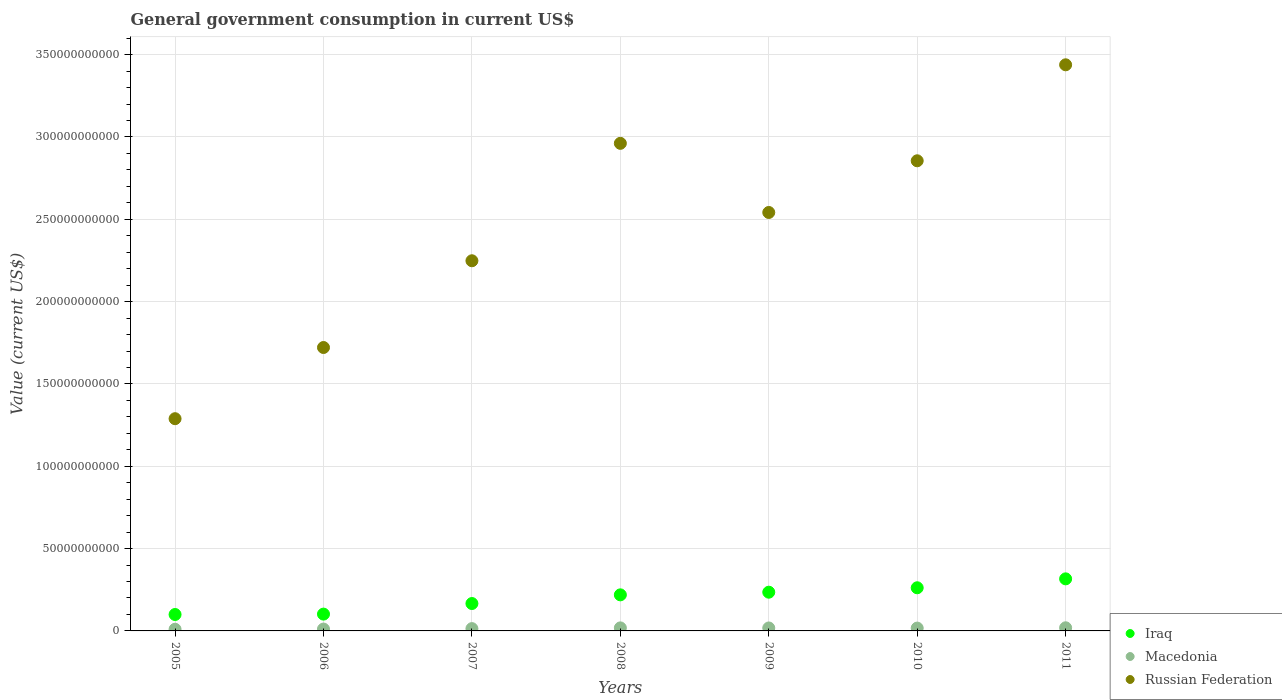How many different coloured dotlines are there?
Keep it short and to the point. 3. What is the government conusmption in Iraq in 2007?
Provide a succinct answer. 1.66e+1. Across all years, what is the maximum government conusmption in Russian Federation?
Your answer should be very brief. 3.44e+11. Across all years, what is the minimum government conusmption in Russian Federation?
Your answer should be very brief. 1.29e+11. In which year was the government conusmption in Russian Federation minimum?
Offer a very short reply. 2005. What is the total government conusmption in Iraq in the graph?
Provide a short and direct response. 1.40e+11. What is the difference between the government conusmption in Macedonia in 2006 and that in 2010?
Your answer should be very brief. -5.88e+08. What is the difference between the government conusmption in Macedonia in 2005 and the government conusmption in Iraq in 2009?
Ensure brevity in your answer.  -2.25e+1. What is the average government conusmption in Macedonia per year?
Offer a very short reply. 1.54e+09. In the year 2011, what is the difference between the government conusmption in Macedonia and government conusmption in Iraq?
Your answer should be compact. -2.97e+1. What is the ratio of the government conusmption in Macedonia in 2007 to that in 2009?
Keep it short and to the point. 0.78. Is the government conusmption in Russian Federation in 2005 less than that in 2007?
Provide a short and direct response. Yes. What is the difference between the highest and the second highest government conusmption in Macedonia?
Give a very brief answer. 6.01e+07. What is the difference between the highest and the lowest government conusmption in Russian Federation?
Keep it short and to the point. 2.15e+11. Is it the case that in every year, the sum of the government conusmption in Russian Federation and government conusmption in Iraq  is greater than the government conusmption in Macedonia?
Your answer should be compact. Yes. Is the government conusmption in Iraq strictly greater than the government conusmption in Macedonia over the years?
Offer a terse response. Yes. Is the government conusmption in Russian Federation strictly less than the government conusmption in Macedonia over the years?
Provide a short and direct response. No. How many dotlines are there?
Provide a short and direct response. 3. How many years are there in the graph?
Your response must be concise. 7. What is the difference between two consecutive major ticks on the Y-axis?
Ensure brevity in your answer.  5.00e+1. Are the values on the major ticks of Y-axis written in scientific E-notation?
Your answer should be compact. No. How are the legend labels stacked?
Give a very brief answer. Vertical. What is the title of the graph?
Make the answer very short. General government consumption in current US$. Does "North America" appear as one of the legend labels in the graph?
Offer a terse response. No. What is the label or title of the Y-axis?
Your answer should be compact. Value (current US$). What is the Value (current US$) in Iraq in 2005?
Your answer should be compact. 9.98e+09. What is the Value (current US$) of Macedonia in 2005?
Your answer should be very brief. 1.01e+09. What is the Value (current US$) in Russian Federation in 2005?
Provide a succinct answer. 1.29e+11. What is the Value (current US$) of Iraq in 2006?
Offer a terse response. 1.02e+1. What is the Value (current US$) of Macedonia in 2006?
Your answer should be very brief. 1.13e+09. What is the Value (current US$) in Russian Federation in 2006?
Offer a terse response. 1.72e+11. What is the Value (current US$) in Iraq in 2007?
Provide a short and direct response. 1.66e+1. What is the Value (current US$) in Macedonia in 2007?
Ensure brevity in your answer.  1.40e+09. What is the Value (current US$) in Russian Federation in 2007?
Provide a succinct answer. 2.25e+11. What is the Value (current US$) in Iraq in 2008?
Your answer should be compact. 2.19e+1. What is the Value (current US$) of Macedonia in 2008?
Offer a terse response. 1.84e+09. What is the Value (current US$) of Russian Federation in 2008?
Provide a succinct answer. 2.96e+11. What is the Value (current US$) in Iraq in 2009?
Offer a very short reply. 2.35e+1. What is the Value (current US$) in Macedonia in 2009?
Provide a short and direct response. 1.79e+09. What is the Value (current US$) in Russian Federation in 2009?
Ensure brevity in your answer.  2.54e+11. What is the Value (current US$) of Iraq in 2010?
Offer a terse response. 2.62e+1. What is the Value (current US$) of Macedonia in 2010?
Your answer should be very brief. 1.72e+09. What is the Value (current US$) in Russian Federation in 2010?
Your answer should be very brief. 2.86e+11. What is the Value (current US$) of Iraq in 2011?
Offer a very short reply. 3.16e+1. What is the Value (current US$) of Macedonia in 2011?
Offer a very short reply. 1.90e+09. What is the Value (current US$) in Russian Federation in 2011?
Keep it short and to the point. 3.44e+11. Across all years, what is the maximum Value (current US$) of Iraq?
Ensure brevity in your answer.  3.16e+1. Across all years, what is the maximum Value (current US$) of Macedonia?
Give a very brief answer. 1.90e+09. Across all years, what is the maximum Value (current US$) of Russian Federation?
Provide a succinct answer. 3.44e+11. Across all years, what is the minimum Value (current US$) of Iraq?
Offer a very short reply. 9.98e+09. Across all years, what is the minimum Value (current US$) of Macedonia?
Make the answer very short. 1.01e+09. Across all years, what is the minimum Value (current US$) in Russian Federation?
Your answer should be very brief. 1.29e+11. What is the total Value (current US$) of Iraq in the graph?
Your response must be concise. 1.40e+11. What is the total Value (current US$) of Macedonia in the graph?
Your answer should be compact. 1.08e+1. What is the total Value (current US$) of Russian Federation in the graph?
Offer a very short reply. 1.71e+12. What is the difference between the Value (current US$) in Iraq in 2005 and that in 2006?
Your response must be concise. -2.36e+08. What is the difference between the Value (current US$) in Macedonia in 2005 and that in 2006?
Offer a terse response. -1.20e+08. What is the difference between the Value (current US$) in Russian Federation in 2005 and that in 2006?
Ensure brevity in your answer.  -4.32e+1. What is the difference between the Value (current US$) in Iraq in 2005 and that in 2007?
Offer a terse response. -6.66e+09. What is the difference between the Value (current US$) of Macedonia in 2005 and that in 2007?
Provide a succinct answer. -3.88e+08. What is the difference between the Value (current US$) of Russian Federation in 2005 and that in 2007?
Give a very brief answer. -9.59e+1. What is the difference between the Value (current US$) of Iraq in 2005 and that in 2008?
Your answer should be compact. -1.19e+1. What is the difference between the Value (current US$) in Macedonia in 2005 and that in 2008?
Your answer should be compact. -8.29e+08. What is the difference between the Value (current US$) of Russian Federation in 2005 and that in 2008?
Keep it short and to the point. -1.67e+11. What is the difference between the Value (current US$) in Iraq in 2005 and that in 2009?
Your answer should be compact. -1.35e+1. What is the difference between the Value (current US$) in Macedonia in 2005 and that in 2009?
Give a very brief answer. -7.80e+08. What is the difference between the Value (current US$) of Russian Federation in 2005 and that in 2009?
Give a very brief answer. -1.25e+11. What is the difference between the Value (current US$) in Iraq in 2005 and that in 2010?
Provide a short and direct response. -1.62e+1. What is the difference between the Value (current US$) in Macedonia in 2005 and that in 2010?
Make the answer very short. -7.08e+08. What is the difference between the Value (current US$) in Russian Federation in 2005 and that in 2010?
Your response must be concise. -1.57e+11. What is the difference between the Value (current US$) of Iraq in 2005 and that in 2011?
Offer a terse response. -2.16e+1. What is the difference between the Value (current US$) in Macedonia in 2005 and that in 2011?
Your answer should be compact. -8.89e+08. What is the difference between the Value (current US$) of Russian Federation in 2005 and that in 2011?
Provide a succinct answer. -2.15e+11. What is the difference between the Value (current US$) of Iraq in 2006 and that in 2007?
Offer a terse response. -6.42e+09. What is the difference between the Value (current US$) of Macedonia in 2006 and that in 2007?
Ensure brevity in your answer.  -2.68e+08. What is the difference between the Value (current US$) in Russian Federation in 2006 and that in 2007?
Provide a succinct answer. -5.27e+1. What is the difference between the Value (current US$) in Iraq in 2006 and that in 2008?
Ensure brevity in your answer.  -1.17e+1. What is the difference between the Value (current US$) of Macedonia in 2006 and that in 2008?
Provide a short and direct response. -7.09e+08. What is the difference between the Value (current US$) in Russian Federation in 2006 and that in 2008?
Your answer should be very brief. -1.24e+11. What is the difference between the Value (current US$) in Iraq in 2006 and that in 2009?
Your response must be concise. -1.33e+1. What is the difference between the Value (current US$) of Macedonia in 2006 and that in 2009?
Keep it short and to the point. -6.61e+08. What is the difference between the Value (current US$) of Russian Federation in 2006 and that in 2009?
Offer a very short reply. -8.20e+1. What is the difference between the Value (current US$) in Iraq in 2006 and that in 2010?
Your answer should be very brief. -1.60e+1. What is the difference between the Value (current US$) in Macedonia in 2006 and that in 2010?
Provide a short and direct response. -5.88e+08. What is the difference between the Value (current US$) in Russian Federation in 2006 and that in 2010?
Provide a succinct answer. -1.13e+11. What is the difference between the Value (current US$) of Iraq in 2006 and that in 2011?
Your answer should be very brief. -2.14e+1. What is the difference between the Value (current US$) of Macedonia in 2006 and that in 2011?
Offer a very short reply. -7.69e+08. What is the difference between the Value (current US$) of Russian Federation in 2006 and that in 2011?
Provide a succinct answer. -1.72e+11. What is the difference between the Value (current US$) of Iraq in 2007 and that in 2008?
Offer a terse response. -5.27e+09. What is the difference between the Value (current US$) in Macedonia in 2007 and that in 2008?
Ensure brevity in your answer.  -4.41e+08. What is the difference between the Value (current US$) in Russian Federation in 2007 and that in 2008?
Offer a very short reply. -7.13e+1. What is the difference between the Value (current US$) in Iraq in 2007 and that in 2009?
Provide a succinct answer. -6.88e+09. What is the difference between the Value (current US$) in Macedonia in 2007 and that in 2009?
Offer a terse response. -3.93e+08. What is the difference between the Value (current US$) of Russian Federation in 2007 and that in 2009?
Offer a terse response. -2.93e+1. What is the difference between the Value (current US$) of Iraq in 2007 and that in 2010?
Your response must be concise. -9.57e+09. What is the difference between the Value (current US$) of Macedonia in 2007 and that in 2010?
Your answer should be compact. -3.20e+08. What is the difference between the Value (current US$) in Russian Federation in 2007 and that in 2010?
Offer a terse response. -6.07e+1. What is the difference between the Value (current US$) of Iraq in 2007 and that in 2011?
Keep it short and to the point. -1.50e+1. What is the difference between the Value (current US$) in Macedonia in 2007 and that in 2011?
Your response must be concise. -5.01e+08. What is the difference between the Value (current US$) in Russian Federation in 2007 and that in 2011?
Keep it short and to the point. -1.19e+11. What is the difference between the Value (current US$) of Iraq in 2008 and that in 2009?
Offer a terse response. -1.61e+09. What is the difference between the Value (current US$) in Macedonia in 2008 and that in 2009?
Your response must be concise. 4.81e+07. What is the difference between the Value (current US$) in Russian Federation in 2008 and that in 2009?
Your answer should be very brief. 4.20e+1. What is the difference between the Value (current US$) of Iraq in 2008 and that in 2010?
Your response must be concise. -4.30e+09. What is the difference between the Value (current US$) of Macedonia in 2008 and that in 2010?
Make the answer very short. 1.21e+08. What is the difference between the Value (current US$) in Russian Federation in 2008 and that in 2010?
Give a very brief answer. 1.06e+1. What is the difference between the Value (current US$) of Iraq in 2008 and that in 2011?
Offer a terse response. -9.71e+09. What is the difference between the Value (current US$) of Macedonia in 2008 and that in 2011?
Your answer should be very brief. -6.01e+07. What is the difference between the Value (current US$) in Russian Federation in 2008 and that in 2011?
Your answer should be compact. -4.77e+1. What is the difference between the Value (current US$) in Iraq in 2009 and that in 2010?
Ensure brevity in your answer.  -2.69e+09. What is the difference between the Value (current US$) of Macedonia in 2009 and that in 2010?
Ensure brevity in your answer.  7.28e+07. What is the difference between the Value (current US$) in Russian Federation in 2009 and that in 2010?
Keep it short and to the point. -3.14e+1. What is the difference between the Value (current US$) of Iraq in 2009 and that in 2011?
Make the answer very short. -8.10e+09. What is the difference between the Value (current US$) in Macedonia in 2009 and that in 2011?
Your answer should be compact. -1.08e+08. What is the difference between the Value (current US$) in Russian Federation in 2009 and that in 2011?
Your answer should be very brief. -8.97e+1. What is the difference between the Value (current US$) of Iraq in 2010 and that in 2011?
Make the answer very short. -5.42e+09. What is the difference between the Value (current US$) of Macedonia in 2010 and that in 2011?
Make the answer very short. -1.81e+08. What is the difference between the Value (current US$) of Russian Federation in 2010 and that in 2011?
Ensure brevity in your answer.  -5.83e+1. What is the difference between the Value (current US$) of Iraq in 2005 and the Value (current US$) of Macedonia in 2006?
Your answer should be compact. 8.84e+09. What is the difference between the Value (current US$) in Iraq in 2005 and the Value (current US$) in Russian Federation in 2006?
Your response must be concise. -1.62e+11. What is the difference between the Value (current US$) of Macedonia in 2005 and the Value (current US$) of Russian Federation in 2006?
Provide a short and direct response. -1.71e+11. What is the difference between the Value (current US$) in Iraq in 2005 and the Value (current US$) in Macedonia in 2007?
Offer a very short reply. 8.57e+09. What is the difference between the Value (current US$) of Iraq in 2005 and the Value (current US$) of Russian Federation in 2007?
Provide a short and direct response. -2.15e+11. What is the difference between the Value (current US$) in Macedonia in 2005 and the Value (current US$) in Russian Federation in 2007?
Your response must be concise. -2.24e+11. What is the difference between the Value (current US$) of Iraq in 2005 and the Value (current US$) of Macedonia in 2008?
Give a very brief answer. 8.13e+09. What is the difference between the Value (current US$) of Iraq in 2005 and the Value (current US$) of Russian Federation in 2008?
Ensure brevity in your answer.  -2.86e+11. What is the difference between the Value (current US$) of Macedonia in 2005 and the Value (current US$) of Russian Federation in 2008?
Give a very brief answer. -2.95e+11. What is the difference between the Value (current US$) in Iraq in 2005 and the Value (current US$) in Macedonia in 2009?
Your response must be concise. 8.18e+09. What is the difference between the Value (current US$) in Iraq in 2005 and the Value (current US$) in Russian Federation in 2009?
Your answer should be very brief. -2.44e+11. What is the difference between the Value (current US$) in Macedonia in 2005 and the Value (current US$) in Russian Federation in 2009?
Provide a short and direct response. -2.53e+11. What is the difference between the Value (current US$) in Iraq in 2005 and the Value (current US$) in Macedonia in 2010?
Make the answer very short. 8.25e+09. What is the difference between the Value (current US$) in Iraq in 2005 and the Value (current US$) in Russian Federation in 2010?
Give a very brief answer. -2.76e+11. What is the difference between the Value (current US$) of Macedonia in 2005 and the Value (current US$) of Russian Federation in 2010?
Your answer should be compact. -2.85e+11. What is the difference between the Value (current US$) of Iraq in 2005 and the Value (current US$) of Macedonia in 2011?
Your answer should be very brief. 8.07e+09. What is the difference between the Value (current US$) of Iraq in 2005 and the Value (current US$) of Russian Federation in 2011?
Ensure brevity in your answer.  -3.34e+11. What is the difference between the Value (current US$) of Macedonia in 2005 and the Value (current US$) of Russian Federation in 2011?
Give a very brief answer. -3.43e+11. What is the difference between the Value (current US$) of Iraq in 2006 and the Value (current US$) of Macedonia in 2007?
Keep it short and to the point. 8.81e+09. What is the difference between the Value (current US$) of Iraq in 2006 and the Value (current US$) of Russian Federation in 2007?
Your answer should be very brief. -2.15e+11. What is the difference between the Value (current US$) in Macedonia in 2006 and the Value (current US$) in Russian Federation in 2007?
Ensure brevity in your answer.  -2.24e+11. What is the difference between the Value (current US$) of Iraq in 2006 and the Value (current US$) of Macedonia in 2008?
Your answer should be very brief. 8.37e+09. What is the difference between the Value (current US$) of Iraq in 2006 and the Value (current US$) of Russian Federation in 2008?
Offer a very short reply. -2.86e+11. What is the difference between the Value (current US$) in Macedonia in 2006 and the Value (current US$) in Russian Federation in 2008?
Provide a short and direct response. -2.95e+11. What is the difference between the Value (current US$) in Iraq in 2006 and the Value (current US$) in Macedonia in 2009?
Provide a succinct answer. 8.42e+09. What is the difference between the Value (current US$) of Iraq in 2006 and the Value (current US$) of Russian Federation in 2009?
Provide a short and direct response. -2.44e+11. What is the difference between the Value (current US$) of Macedonia in 2006 and the Value (current US$) of Russian Federation in 2009?
Keep it short and to the point. -2.53e+11. What is the difference between the Value (current US$) of Iraq in 2006 and the Value (current US$) of Macedonia in 2010?
Give a very brief answer. 8.49e+09. What is the difference between the Value (current US$) of Iraq in 2006 and the Value (current US$) of Russian Federation in 2010?
Your response must be concise. -2.75e+11. What is the difference between the Value (current US$) of Macedonia in 2006 and the Value (current US$) of Russian Federation in 2010?
Offer a very short reply. -2.84e+11. What is the difference between the Value (current US$) in Iraq in 2006 and the Value (current US$) in Macedonia in 2011?
Ensure brevity in your answer.  8.31e+09. What is the difference between the Value (current US$) in Iraq in 2006 and the Value (current US$) in Russian Federation in 2011?
Provide a succinct answer. -3.34e+11. What is the difference between the Value (current US$) of Macedonia in 2006 and the Value (current US$) of Russian Federation in 2011?
Provide a short and direct response. -3.43e+11. What is the difference between the Value (current US$) in Iraq in 2007 and the Value (current US$) in Macedonia in 2008?
Your answer should be compact. 1.48e+1. What is the difference between the Value (current US$) in Iraq in 2007 and the Value (current US$) in Russian Federation in 2008?
Your answer should be compact. -2.80e+11. What is the difference between the Value (current US$) of Macedonia in 2007 and the Value (current US$) of Russian Federation in 2008?
Provide a succinct answer. -2.95e+11. What is the difference between the Value (current US$) of Iraq in 2007 and the Value (current US$) of Macedonia in 2009?
Make the answer very short. 1.48e+1. What is the difference between the Value (current US$) of Iraq in 2007 and the Value (current US$) of Russian Federation in 2009?
Your answer should be compact. -2.38e+11. What is the difference between the Value (current US$) of Macedonia in 2007 and the Value (current US$) of Russian Federation in 2009?
Offer a terse response. -2.53e+11. What is the difference between the Value (current US$) of Iraq in 2007 and the Value (current US$) of Macedonia in 2010?
Your answer should be very brief. 1.49e+1. What is the difference between the Value (current US$) of Iraq in 2007 and the Value (current US$) of Russian Federation in 2010?
Give a very brief answer. -2.69e+11. What is the difference between the Value (current US$) in Macedonia in 2007 and the Value (current US$) in Russian Federation in 2010?
Provide a short and direct response. -2.84e+11. What is the difference between the Value (current US$) in Iraq in 2007 and the Value (current US$) in Macedonia in 2011?
Provide a short and direct response. 1.47e+1. What is the difference between the Value (current US$) in Iraq in 2007 and the Value (current US$) in Russian Federation in 2011?
Your answer should be compact. -3.27e+11. What is the difference between the Value (current US$) in Macedonia in 2007 and the Value (current US$) in Russian Federation in 2011?
Your response must be concise. -3.42e+11. What is the difference between the Value (current US$) in Iraq in 2008 and the Value (current US$) in Macedonia in 2009?
Your answer should be compact. 2.01e+1. What is the difference between the Value (current US$) in Iraq in 2008 and the Value (current US$) in Russian Federation in 2009?
Offer a very short reply. -2.32e+11. What is the difference between the Value (current US$) in Macedonia in 2008 and the Value (current US$) in Russian Federation in 2009?
Offer a terse response. -2.52e+11. What is the difference between the Value (current US$) of Iraq in 2008 and the Value (current US$) of Macedonia in 2010?
Make the answer very short. 2.02e+1. What is the difference between the Value (current US$) in Iraq in 2008 and the Value (current US$) in Russian Federation in 2010?
Offer a very short reply. -2.64e+11. What is the difference between the Value (current US$) of Macedonia in 2008 and the Value (current US$) of Russian Federation in 2010?
Your answer should be compact. -2.84e+11. What is the difference between the Value (current US$) of Iraq in 2008 and the Value (current US$) of Macedonia in 2011?
Make the answer very short. 2.00e+1. What is the difference between the Value (current US$) in Iraq in 2008 and the Value (current US$) in Russian Federation in 2011?
Offer a very short reply. -3.22e+11. What is the difference between the Value (current US$) of Macedonia in 2008 and the Value (current US$) of Russian Federation in 2011?
Your answer should be compact. -3.42e+11. What is the difference between the Value (current US$) in Iraq in 2009 and the Value (current US$) in Macedonia in 2010?
Keep it short and to the point. 2.18e+1. What is the difference between the Value (current US$) in Iraq in 2009 and the Value (current US$) in Russian Federation in 2010?
Make the answer very short. -2.62e+11. What is the difference between the Value (current US$) of Macedonia in 2009 and the Value (current US$) of Russian Federation in 2010?
Provide a short and direct response. -2.84e+11. What is the difference between the Value (current US$) of Iraq in 2009 and the Value (current US$) of Macedonia in 2011?
Offer a very short reply. 2.16e+1. What is the difference between the Value (current US$) of Iraq in 2009 and the Value (current US$) of Russian Federation in 2011?
Provide a succinct answer. -3.20e+11. What is the difference between the Value (current US$) of Macedonia in 2009 and the Value (current US$) of Russian Federation in 2011?
Offer a very short reply. -3.42e+11. What is the difference between the Value (current US$) of Iraq in 2010 and the Value (current US$) of Macedonia in 2011?
Provide a short and direct response. 2.43e+1. What is the difference between the Value (current US$) in Iraq in 2010 and the Value (current US$) in Russian Federation in 2011?
Make the answer very short. -3.18e+11. What is the difference between the Value (current US$) of Macedonia in 2010 and the Value (current US$) of Russian Federation in 2011?
Your answer should be compact. -3.42e+11. What is the average Value (current US$) of Iraq per year?
Provide a short and direct response. 2.00e+1. What is the average Value (current US$) in Macedonia per year?
Your response must be concise. 1.54e+09. What is the average Value (current US$) in Russian Federation per year?
Ensure brevity in your answer.  2.44e+11. In the year 2005, what is the difference between the Value (current US$) in Iraq and Value (current US$) in Macedonia?
Keep it short and to the point. 8.96e+09. In the year 2005, what is the difference between the Value (current US$) of Iraq and Value (current US$) of Russian Federation?
Your response must be concise. -1.19e+11. In the year 2005, what is the difference between the Value (current US$) of Macedonia and Value (current US$) of Russian Federation?
Offer a very short reply. -1.28e+11. In the year 2006, what is the difference between the Value (current US$) of Iraq and Value (current US$) of Macedonia?
Make the answer very short. 9.08e+09. In the year 2006, what is the difference between the Value (current US$) in Iraq and Value (current US$) in Russian Federation?
Keep it short and to the point. -1.62e+11. In the year 2006, what is the difference between the Value (current US$) in Macedonia and Value (current US$) in Russian Federation?
Offer a terse response. -1.71e+11. In the year 2007, what is the difference between the Value (current US$) in Iraq and Value (current US$) in Macedonia?
Your response must be concise. 1.52e+1. In the year 2007, what is the difference between the Value (current US$) in Iraq and Value (current US$) in Russian Federation?
Offer a terse response. -2.08e+11. In the year 2007, what is the difference between the Value (current US$) of Macedonia and Value (current US$) of Russian Federation?
Ensure brevity in your answer.  -2.23e+11. In the year 2008, what is the difference between the Value (current US$) in Iraq and Value (current US$) in Macedonia?
Provide a succinct answer. 2.01e+1. In the year 2008, what is the difference between the Value (current US$) in Iraq and Value (current US$) in Russian Federation?
Offer a very short reply. -2.74e+11. In the year 2008, what is the difference between the Value (current US$) in Macedonia and Value (current US$) in Russian Federation?
Keep it short and to the point. -2.94e+11. In the year 2009, what is the difference between the Value (current US$) of Iraq and Value (current US$) of Macedonia?
Your response must be concise. 2.17e+1. In the year 2009, what is the difference between the Value (current US$) of Iraq and Value (current US$) of Russian Federation?
Make the answer very short. -2.31e+11. In the year 2009, what is the difference between the Value (current US$) in Macedonia and Value (current US$) in Russian Federation?
Provide a succinct answer. -2.52e+11. In the year 2010, what is the difference between the Value (current US$) in Iraq and Value (current US$) in Macedonia?
Give a very brief answer. 2.45e+1. In the year 2010, what is the difference between the Value (current US$) in Iraq and Value (current US$) in Russian Federation?
Offer a terse response. -2.59e+11. In the year 2010, what is the difference between the Value (current US$) in Macedonia and Value (current US$) in Russian Federation?
Ensure brevity in your answer.  -2.84e+11. In the year 2011, what is the difference between the Value (current US$) in Iraq and Value (current US$) in Macedonia?
Keep it short and to the point. 2.97e+1. In the year 2011, what is the difference between the Value (current US$) of Iraq and Value (current US$) of Russian Federation?
Ensure brevity in your answer.  -3.12e+11. In the year 2011, what is the difference between the Value (current US$) of Macedonia and Value (current US$) of Russian Federation?
Provide a succinct answer. -3.42e+11. What is the ratio of the Value (current US$) of Iraq in 2005 to that in 2006?
Offer a terse response. 0.98. What is the ratio of the Value (current US$) of Macedonia in 2005 to that in 2006?
Give a very brief answer. 0.89. What is the ratio of the Value (current US$) of Russian Federation in 2005 to that in 2006?
Offer a very short reply. 0.75. What is the ratio of the Value (current US$) of Iraq in 2005 to that in 2007?
Your response must be concise. 0.6. What is the ratio of the Value (current US$) of Macedonia in 2005 to that in 2007?
Offer a terse response. 0.72. What is the ratio of the Value (current US$) of Russian Federation in 2005 to that in 2007?
Your answer should be compact. 0.57. What is the ratio of the Value (current US$) in Iraq in 2005 to that in 2008?
Offer a very short reply. 0.46. What is the ratio of the Value (current US$) of Macedonia in 2005 to that in 2008?
Offer a terse response. 0.55. What is the ratio of the Value (current US$) in Russian Federation in 2005 to that in 2008?
Your answer should be very brief. 0.44. What is the ratio of the Value (current US$) of Iraq in 2005 to that in 2009?
Give a very brief answer. 0.42. What is the ratio of the Value (current US$) of Macedonia in 2005 to that in 2009?
Your answer should be compact. 0.56. What is the ratio of the Value (current US$) in Russian Federation in 2005 to that in 2009?
Provide a short and direct response. 0.51. What is the ratio of the Value (current US$) of Iraq in 2005 to that in 2010?
Provide a succinct answer. 0.38. What is the ratio of the Value (current US$) in Macedonia in 2005 to that in 2010?
Offer a very short reply. 0.59. What is the ratio of the Value (current US$) of Russian Federation in 2005 to that in 2010?
Your response must be concise. 0.45. What is the ratio of the Value (current US$) in Iraq in 2005 to that in 2011?
Offer a very short reply. 0.32. What is the ratio of the Value (current US$) in Macedonia in 2005 to that in 2011?
Ensure brevity in your answer.  0.53. What is the ratio of the Value (current US$) of Russian Federation in 2005 to that in 2011?
Provide a short and direct response. 0.37. What is the ratio of the Value (current US$) of Iraq in 2006 to that in 2007?
Keep it short and to the point. 0.61. What is the ratio of the Value (current US$) of Macedonia in 2006 to that in 2007?
Offer a very short reply. 0.81. What is the ratio of the Value (current US$) of Russian Federation in 2006 to that in 2007?
Give a very brief answer. 0.77. What is the ratio of the Value (current US$) of Iraq in 2006 to that in 2008?
Offer a very short reply. 0.47. What is the ratio of the Value (current US$) in Macedonia in 2006 to that in 2008?
Offer a terse response. 0.62. What is the ratio of the Value (current US$) of Russian Federation in 2006 to that in 2008?
Ensure brevity in your answer.  0.58. What is the ratio of the Value (current US$) in Iraq in 2006 to that in 2009?
Keep it short and to the point. 0.43. What is the ratio of the Value (current US$) of Macedonia in 2006 to that in 2009?
Provide a succinct answer. 0.63. What is the ratio of the Value (current US$) of Russian Federation in 2006 to that in 2009?
Make the answer very short. 0.68. What is the ratio of the Value (current US$) of Iraq in 2006 to that in 2010?
Ensure brevity in your answer.  0.39. What is the ratio of the Value (current US$) of Macedonia in 2006 to that in 2010?
Provide a succinct answer. 0.66. What is the ratio of the Value (current US$) of Russian Federation in 2006 to that in 2010?
Your answer should be very brief. 0.6. What is the ratio of the Value (current US$) in Iraq in 2006 to that in 2011?
Keep it short and to the point. 0.32. What is the ratio of the Value (current US$) of Macedonia in 2006 to that in 2011?
Give a very brief answer. 0.6. What is the ratio of the Value (current US$) of Russian Federation in 2006 to that in 2011?
Offer a very short reply. 0.5. What is the ratio of the Value (current US$) of Iraq in 2007 to that in 2008?
Make the answer very short. 0.76. What is the ratio of the Value (current US$) in Macedonia in 2007 to that in 2008?
Ensure brevity in your answer.  0.76. What is the ratio of the Value (current US$) of Russian Federation in 2007 to that in 2008?
Provide a short and direct response. 0.76. What is the ratio of the Value (current US$) of Iraq in 2007 to that in 2009?
Your response must be concise. 0.71. What is the ratio of the Value (current US$) in Macedonia in 2007 to that in 2009?
Your response must be concise. 0.78. What is the ratio of the Value (current US$) of Russian Federation in 2007 to that in 2009?
Keep it short and to the point. 0.88. What is the ratio of the Value (current US$) of Iraq in 2007 to that in 2010?
Keep it short and to the point. 0.63. What is the ratio of the Value (current US$) of Macedonia in 2007 to that in 2010?
Provide a short and direct response. 0.81. What is the ratio of the Value (current US$) in Russian Federation in 2007 to that in 2010?
Provide a short and direct response. 0.79. What is the ratio of the Value (current US$) of Iraq in 2007 to that in 2011?
Your answer should be compact. 0.53. What is the ratio of the Value (current US$) of Macedonia in 2007 to that in 2011?
Give a very brief answer. 0.74. What is the ratio of the Value (current US$) in Russian Federation in 2007 to that in 2011?
Your response must be concise. 0.65. What is the ratio of the Value (current US$) in Iraq in 2008 to that in 2009?
Your answer should be very brief. 0.93. What is the ratio of the Value (current US$) of Macedonia in 2008 to that in 2009?
Your response must be concise. 1.03. What is the ratio of the Value (current US$) in Russian Federation in 2008 to that in 2009?
Ensure brevity in your answer.  1.17. What is the ratio of the Value (current US$) in Iraq in 2008 to that in 2010?
Offer a terse response. 0.84. What is the ratio of the Value (current US$) in Macedonia in 2008 to that in 2010?
Your answer should be very brief. 1.07. What is the ratio of the Value (current US$) in Russian Federation in 2008 to that in 2010?
Your answer should be compact. 1.04. What is the ratio of the Value (current US$) in Iraq in 2008 to that in 2011?
Make the answer very short. 0.69. What is the ratio of the Value (current US$) of Macedonia in 2008 to that in 2011?
Your answer should be compact. 0.97. What is the ratio of the Value (current US$) of Russian Federation in 2008 to that in 2011?
Make the answer very short. 0.86. What is the ratio of the Value (current US$) of Iraq in 2009 to that in 2010?
Make the answer very short. 0.9. What is the ratio of the Value (current US$) of Macedonia in 2009 to that in 2010?
Your answer should be very brief. 1.04. What is the ratio of the Value (current US$) of Russian Federation in 2009 to that in 2010?
Offer a very short reply. 0.89. What is the ratio of the Value (current US$) in Iraq in 2009 to that in 2011?
Your answer should be very brief. 0.74. What is the ratio of the Value (current US$) of Macedonia in 2009 to that in 2011?
Offer a terse response. 0.94. What is the ratio of the Value (current US$) in Russian Federation in 2009 to that in 2011?
Your response must be concise. 0.74. What is the ratio of the Value (current US$) in Iraq in 2010 to that in 2011?
Offer a terse response. 0.83. What is the ratio of the Value (current US$) of Macedonia in 2010 to that in 2011?
Your response must be concise. 0.9. What is the ratio of the Value (current US$) in Russian Federation in 2010 to that in 2011?
Ensure brevity in your answer.  0.83. What is the difference between the highest and the second highest Value (current US$) of Iraq?
Ensure brevity in your answer.  5.42e+09. What is the difference between the highest and the second highest Value (current US$) of Macedonia?
Offer a very short reply. 6.01e+07. What is the difference between the highest and the second highest Value (current US$) of Russian Federation?
Offer a very short reply. 4.77e+1. What is the difference between the highest and the lowest Value (current US$) of Iraq?
Provide a succinct answer. 2.16e+1. What is the difference between the highest and the lowest Value (current US$) of Macedonia?
Make the answer very short. 8.89e+08. What is the difference between the highest and the lowest Value (current US$) in Russian Federation?
Your answer should be compact. 2.15e+11. 